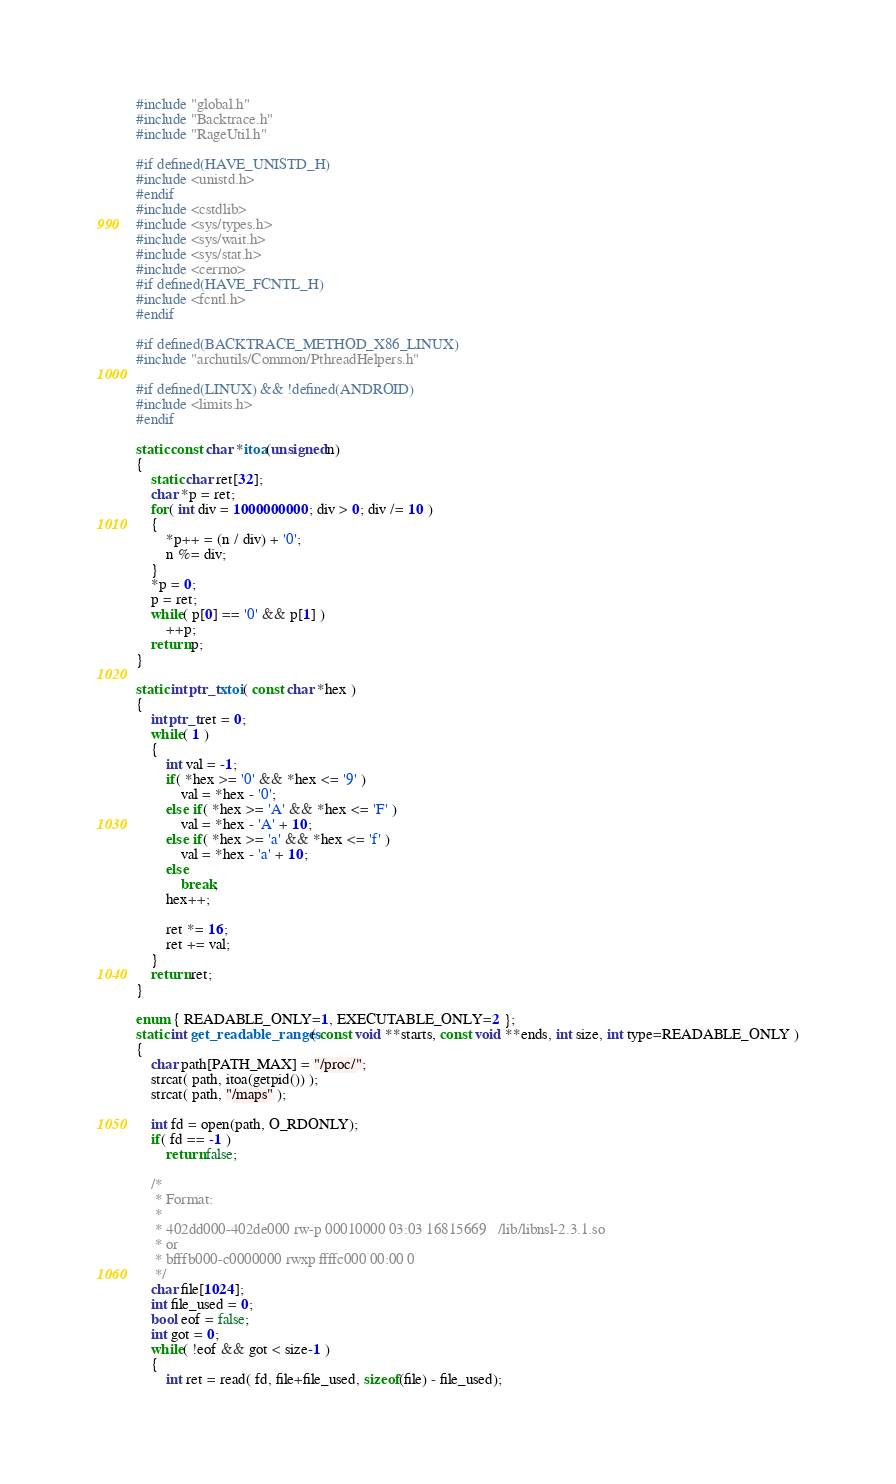Convert code to text. <code><loc_0><loc_0><loc_500><loc_500><_C++_>#include "global.h"
#include "Backtrace.h"
#include "RageUtil.h"

#if defined(HAVE_UNISTD_H)
#include <unistd.h>
#endif
#include <cstdlib>
#include <sys/types.h>
#include <sys/wait.h>
#include <sys/stat.h>
#include <cerrno>
#if defined(HAVE_FCNTL_H)
#include <fcntl.h>
#endif

#if defined(BACKTRACE_METHOD_X86_LINUX)
#include "archutils/Common/PthreadHelpers.h"

#if defined(LINUX) && !defined(ANDROID)
#include <limits.h>
#endif

static const char *itoa(unsigned n)
{
	static char ret[32];
	char *p = ret;
	for( int div = 1000000000; div > 0; div /= 10 )
	{
		*p++ = (n / div) + '0';
		n %= div;
	}
	*p = 0;
	p = ret;
	while( p[0] == '0' && p[1] )
		++p;
	return p;
}

static intptr_t xtoi( const char *hex )
{
	intptr_t ret = 0;
	while( 1 )
	{
		int val = -1;
		if( *hex >= '0' && *hex <= '9' )
			val = *hex - '0';
		else if( *hex >= 'A' && *hex <= 'F' )
			val = *hex - 'A' + 10;
		else if( *hex >= 'a' && *hex <= 'f' )
			val = *hex - 'a' + 10;
		else
			break;
		hex++;

		ret *= 16;
		ret += val;
	}
	return ret;
}

enum { READABLE_ONLY=1, EXECUTABLE_ONLY=2 };
static int get_readable_ranges( const void **starts, const void **ends, int size, int type=READABLE_ONLY )
{
	char path[PATH_MAX] = "/proc/";
	strcat( path, itoa(getpid()) );
	strcat( path, "/maps" );

	int fd = open(path, O_RDONLY);
	if( fd == -1 )
		return false;

	/*
	 * Format:
	 *
	 * 402dd000-402de000 rw-p 00010000 03:03 16815669   /lib/libnsl-2.3.1.so
	 * or
	 * bfffb000-c0000000 rwxp ffffc000 00:00 0
	 */
	char file[1024];
	int file_used = 0;
	bool eof = false;
	int got = 0;
	while( !eof && got < size-1 )
	{
		int ret = read( fd, file+file_used, sizeof(file) - file_used);</code> 